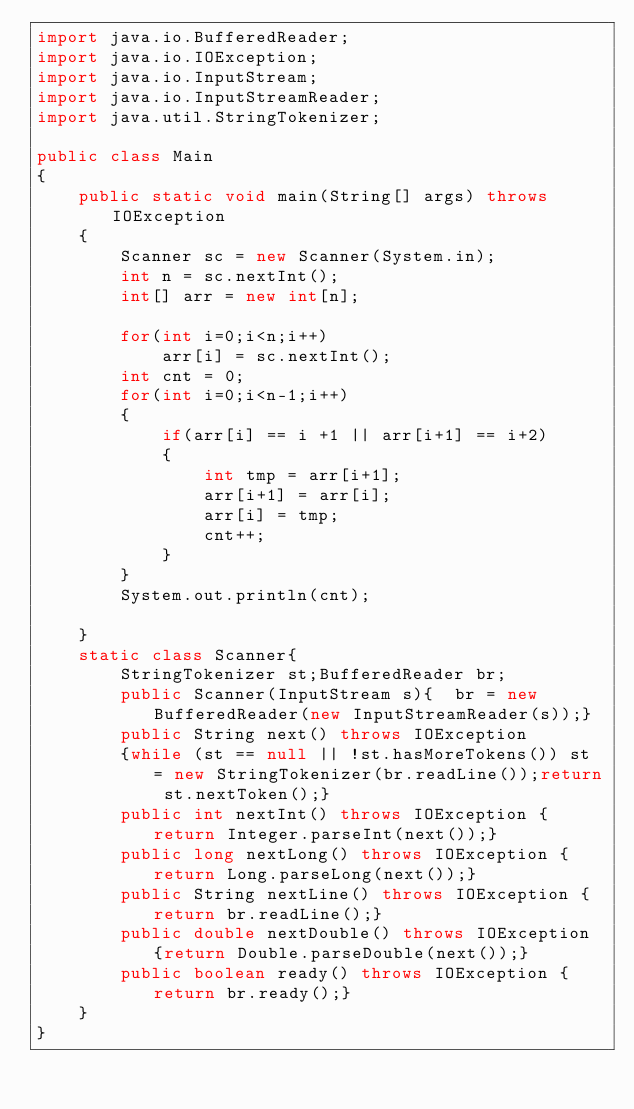Convert code to text. <code><loc_0><loc_0><loc_500><loc_500><_Java_>import java.io.BufferedReader;
import java.io.IOException;
import java.io.InputStream;
import java.io.InputStreamReader;
import java.util.StringTokenizer;

public class Main
{
	public static void main(String[] args) throws IOException
	{
		Scanner sc = new Scanner(System.in);
		int n = sc.nextInt();
		int[] arr = new int[n];
		
		for(int i=0;i<n;i++)
			arr[i] = sc.nextInt();
		int cnt = 0;
		for(int i=0;i<n-1;i++)
		{
			if(arr[i] == i +1 || arr[i+1] == i+2)
			{
				int tmp = arr[i+1];
				arr[i+1] = arr[i];
				arr[i] = tmp;
				cnt++;
			}
		}
		System.out.println(cnt);
		
	}
	static class Scanner{
		StringTokenizer st;BufferedReader br;
		public Scanner(InputStream s){	br = new BufferedReader(new InputStreamReader(s));}
		public String next() throws IOException 
		{while (st == null || !st.hasMoreTokens()) st = new StringTokenizer(br.readLine());return st.nextToken();}
		public int nextInt() throws IOException {return Integer.parseInt(next());}
		public long nextLong() throws IOException {return Long.parseLong(next());}
		public String nextLine() throws IOException {return br.readLine();}
		public double nextDouble() throws IOException {return Double.parseDouble(next());}
		public boolean ready() throws IOException {return br.ready();}
	}
}
</code> 